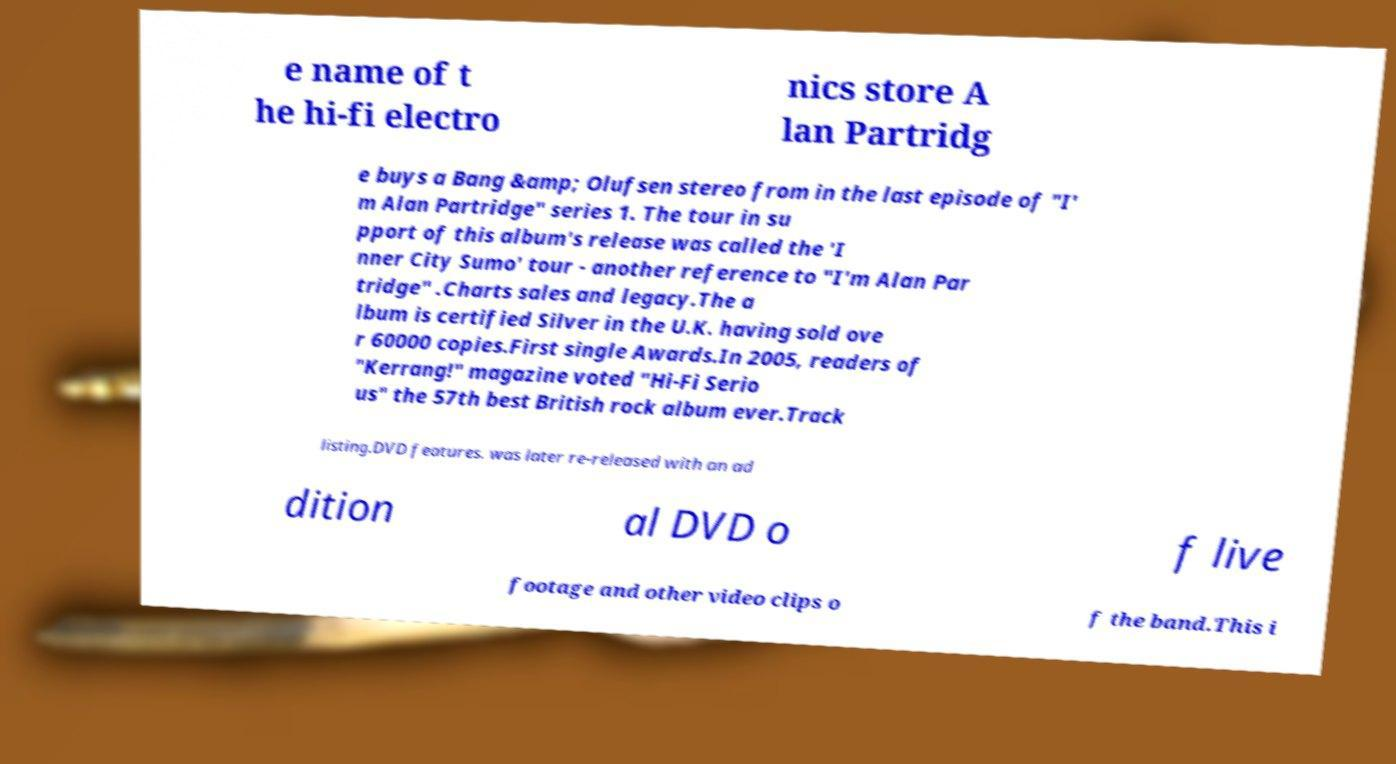Please read and relay the text visible in this image. What does it say? e name of t he hi-fi electro nics store A lan Partridg e buys a Bang &amp; Olufsen stereo from in the last episode of "I' m Alan Partridge" series 1. The tour in su pport of this album's release was called the 'I nner City Sumo' tour - another reference to "I'm Alan Par tridge" .Charts sales and legacy.The a lbum is certified Silver in the U.K. having sold ove r 60000 copies.First single Awards.In 2005, readers of "Kerrang!" magazine voted "Hi-Fi Serio us" the 57th best British rock album ever.Track listing.DVD features. was later re-released with an ad dition al DVD o f live footage and other video clips o f the band.This i 